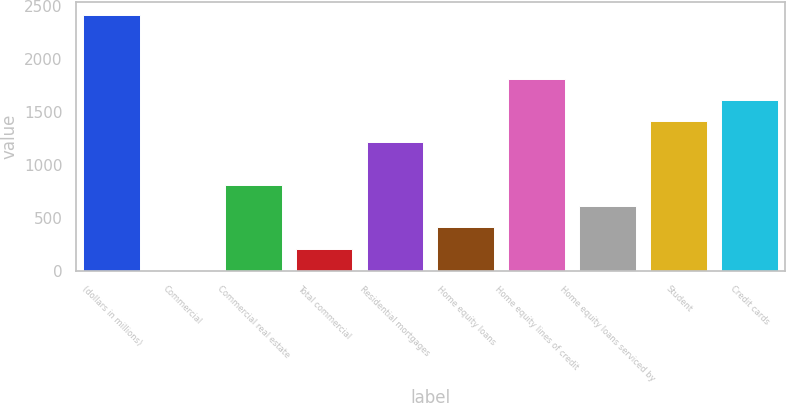Convert chart. <chart><loc_0><loc_0><loc_500><loc_500><bar_chart><fcel>(dollars in millions)<fcel>Commercial<fcel>Commercial real estate<fcel>Total commercial<fcel>Residential mortgages<fcel>Home equity loans<fcel>Home equity lines of credit<fcel>Home equity loans serviced by<fcel>Student<fcel>Credit cards<nl><fcel>2413<fcel>13<fcel>813<fcel>213<fcel>1213<fcel>413<fcel>1813<fcel>613<fcel>1413<fcel>1613<nl></chart> 